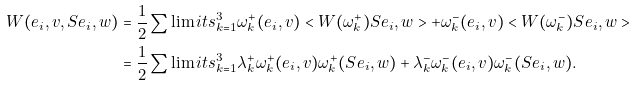Convert formula to latex. <formula><loc_0><loc_0><loc_500><loc_500>W ( e _ { i } , v , S e _ { i } , w ) & = \frac { 1 } { 2 } \sum \lim i t s _ { k = 1 } ^ { 3 } \omega _ { k } ^ { + } ( e _ { i } , v ) < W ( \omega _ { k } ^ { + } ) S e _ { i } , w > + \omega _ { k } ^ { - } ( e _ { i } , v ) < W ( \omega _ { k } ^ { - } ) S e _ { i } , w > \\ & = \frac { 1 } { 2 } \sum \lim i t s _ { k = 1 } ^ { 3 } \lambda _ { k } ^ { + } \omega _ { k } ^ { + } ( e _ { i } , v ) \omega _ { k } ^ { + } ( S e _ { i } , w ) + \lambda _ { k } ^ { - } \omega _ { k } ^ { - } ( e _ { i } , v ) \omega _ { k } ^ { - } ( S e _ { i } , w ) .</formula> 